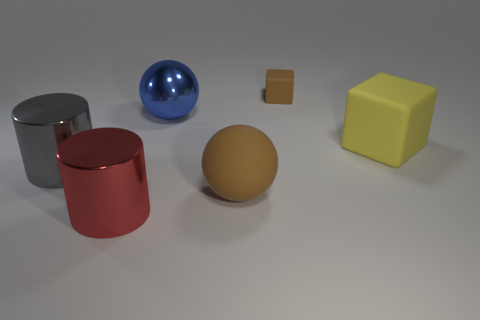Subtract 1 cylinders. How many cylinders are left? 1 Add 1 large blue cubes. How many objects exist? 7 Subtract all brown spheres. Subtract all blue cubes. How many spheres are left? 1 Subtract all yellow spheres. How many yellow cubes are left? 1 Subtract all blue shiny balls. Subtract all tiny yellow shiny cylinders. How many objects are left? 5 Add 3 red metallic cylinders. How many red metallic cylinders are left? 4 Add 5 green metallic things. How many green metallic things exist? 5 Subtract 0 purple blocks. How many objects are left? 6 